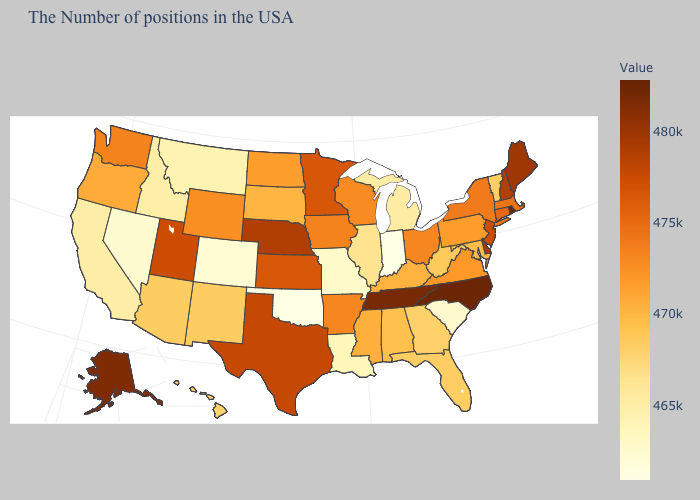Does Rhode Island have the highest value in the USA?
Keep it brief. Yes. Does Indiana have the lowest value in the USA?
Be succinct. Yes. Does Alaska have the highest value in the West?
Write a very short answer. Yes. Does the map have missing data?
Answer briefly. No. Does New Jersey have a higher value than North Carolina?
Answer briefly. No. Is the legend a continuous bar?
Answer briefly. Yes. 